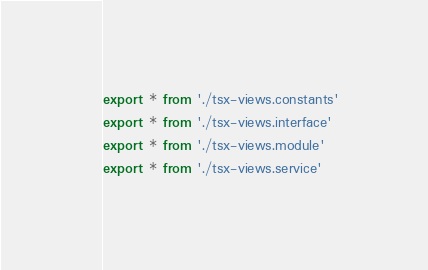Convert code to text. <code><loc_0><loc_0><loc_500><loc_500><_TypeScript_>export * from './tsx-views.constants'
export * from './tsx-views.interface'
export * from './tsx-views.module'
export * from './tsx-views.service'
</code> 